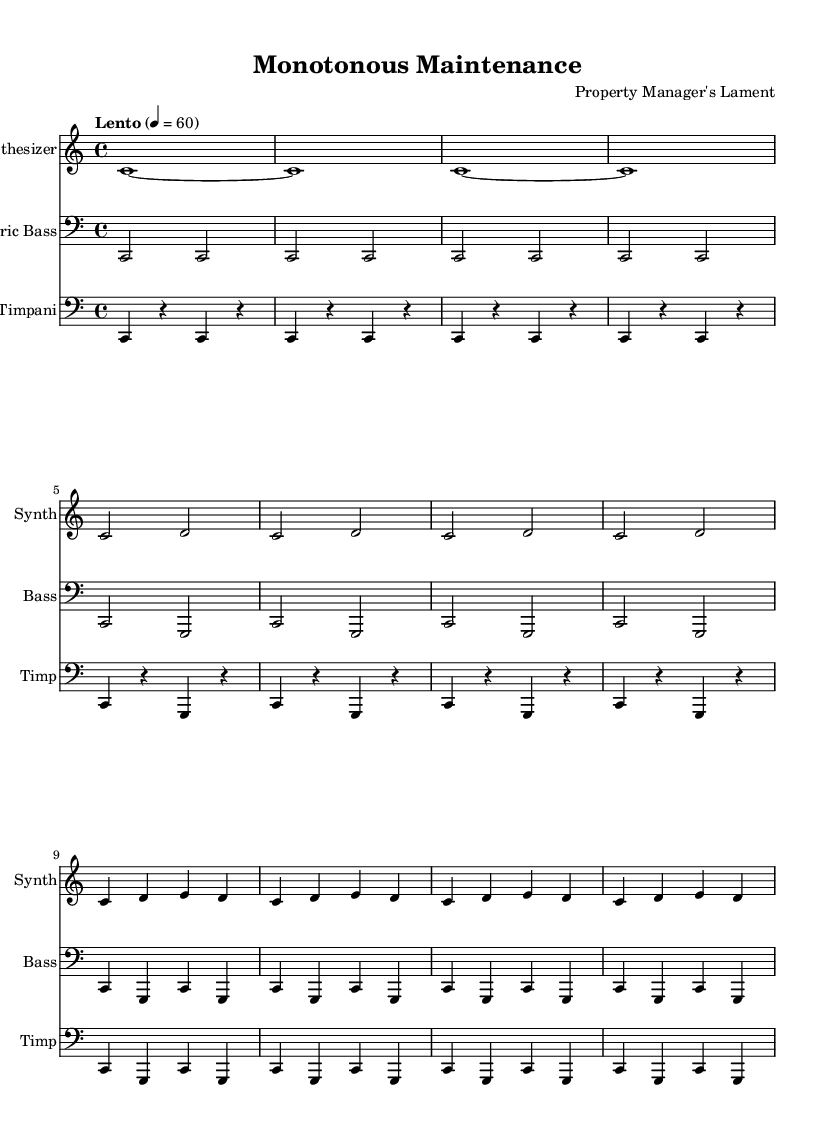What is the key signature of this music? The key signature is C major, which has no sharps or flats indicated on the staff.
Answer: C major What is the time signature of this music? The time signature is 4/4, which means there are four beats in each measure. This is indicated at the beginning of the score.
Answer: 4/4 What is the tempo marking of this piece? The tempo marking states "Lento" with a metronome marking of 60 beats per minute, which indicates a slow tempo.
Answer: Lento, 60 How many variations are presented in the music? The music presents two variations after the main theme, as each variation is clearly labeled in the sequence of the score.
Answer: Two What instrument plays the main theme first? The synthesizer instrument is the first to introduce the main theme, as indicated by the ordering in the score.
Answer: Synthesizer What rhythmic pattern is predominantly used in the timpani part? The timpani predominantly uses a pattern of alternating notes and rests, forming a repeating rhythmic structure.
Answer: Alternating notes and rests What is the function of the electric bass in this piece? The electric bass functions to provide a harmonic foundation and support the main melodic lines, as it plays repetitive bass notes.
Answer: Harmonic foundation 